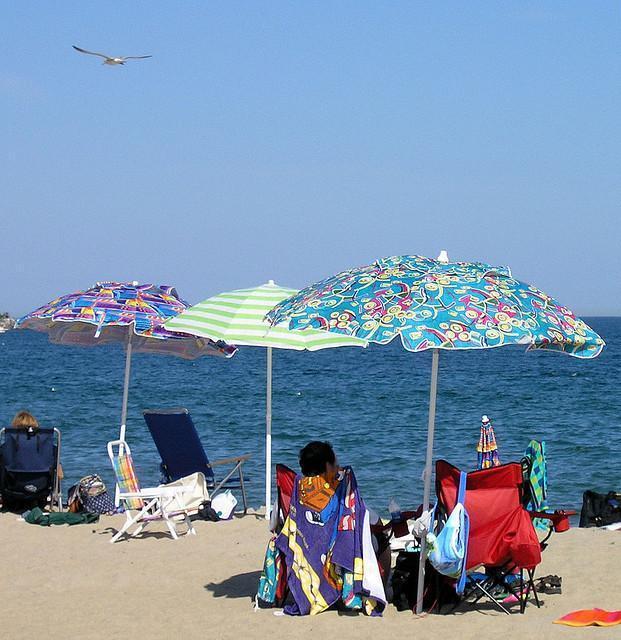How many chairs are there?
Give a very brief answer. 4. How many umbrellas are visible?
Give a very brief answer. 3. 